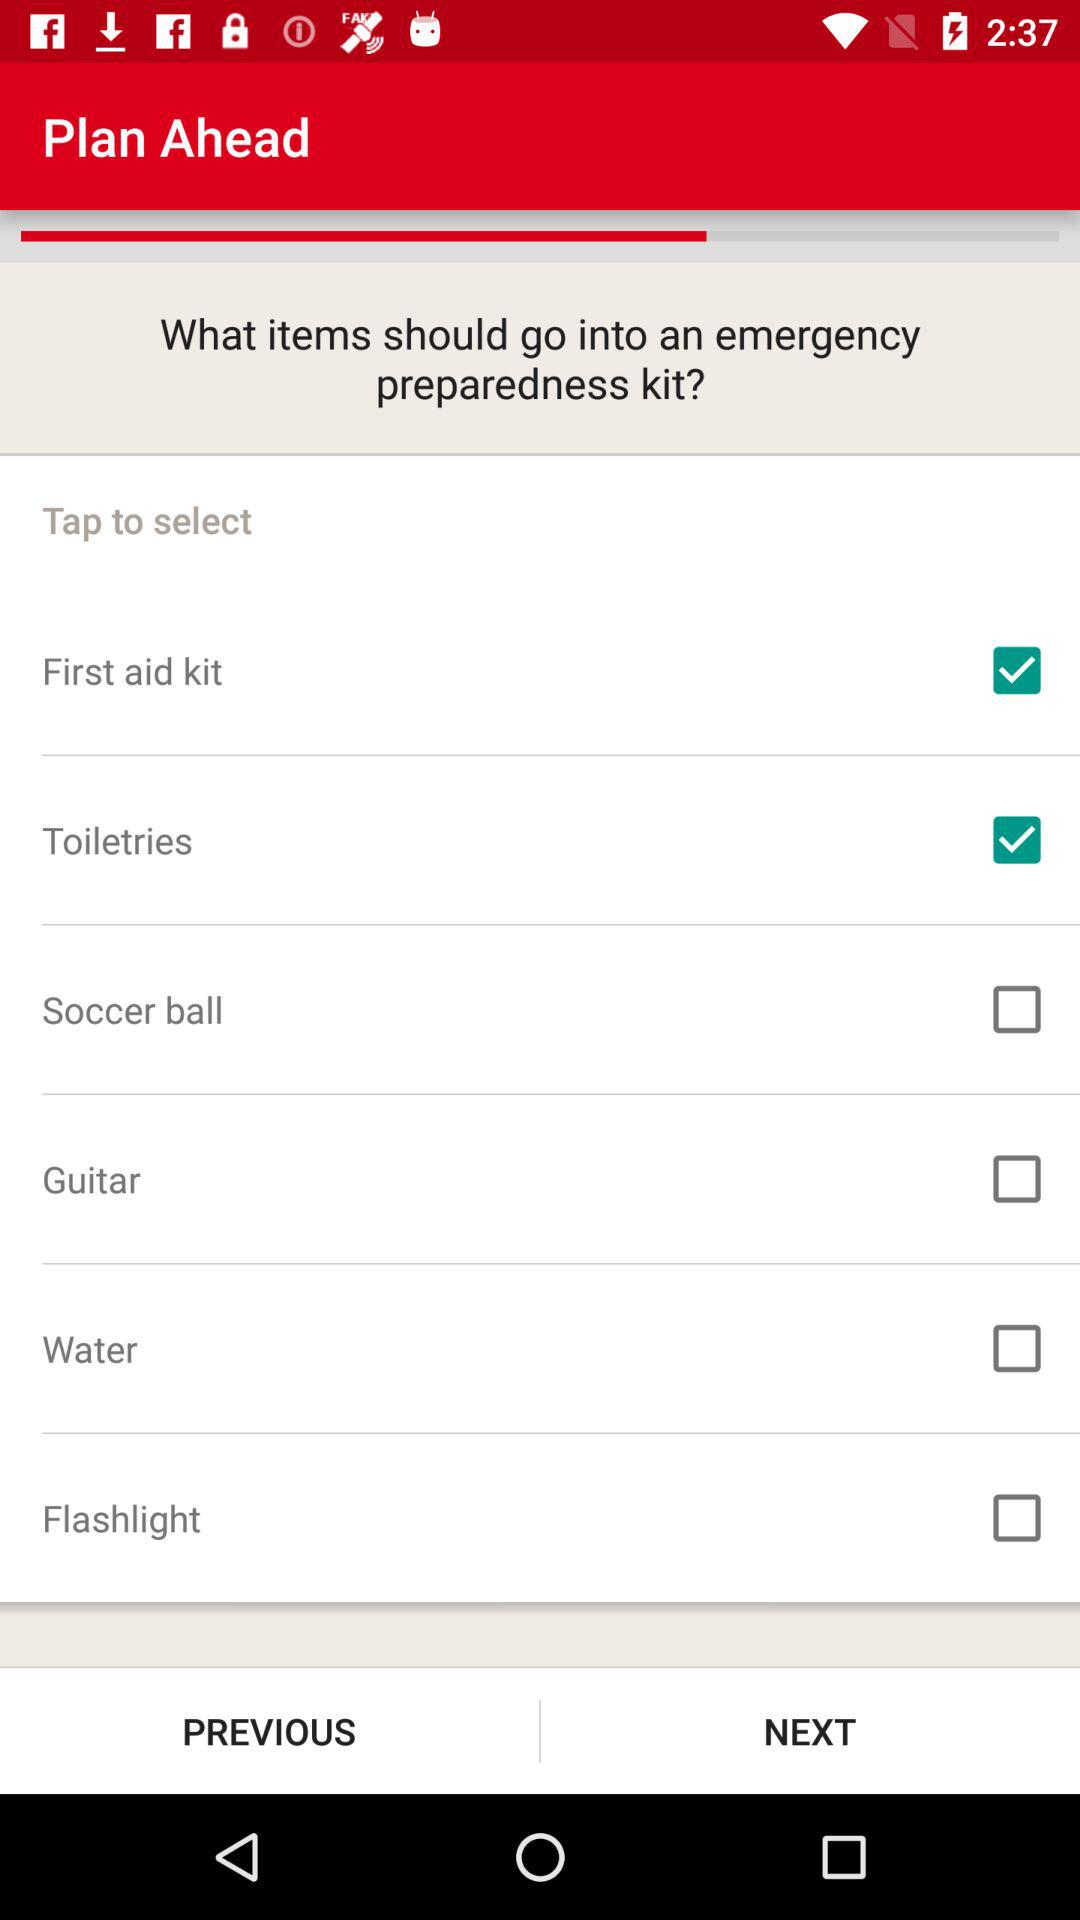How many items are not checked?
Answer the question using a single word or phrase. 4 